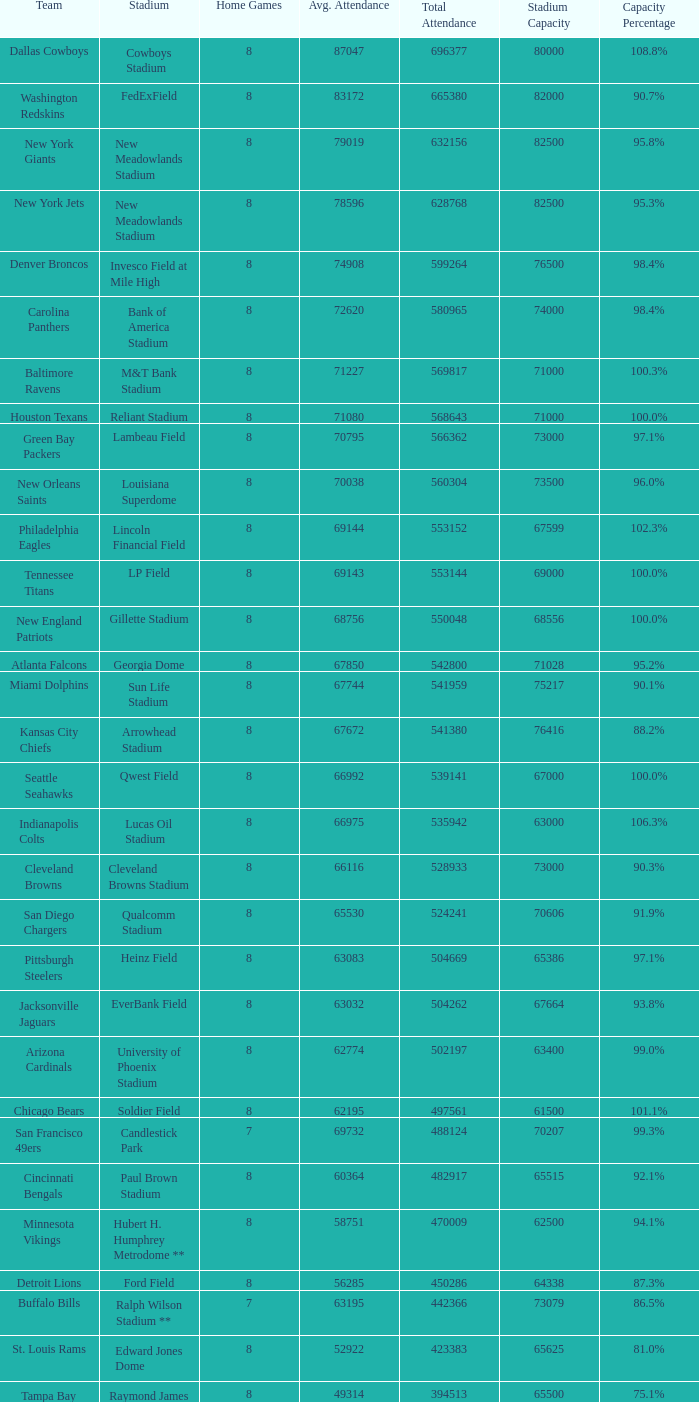What was the total attendance of the New York Giants? 632156.0. 